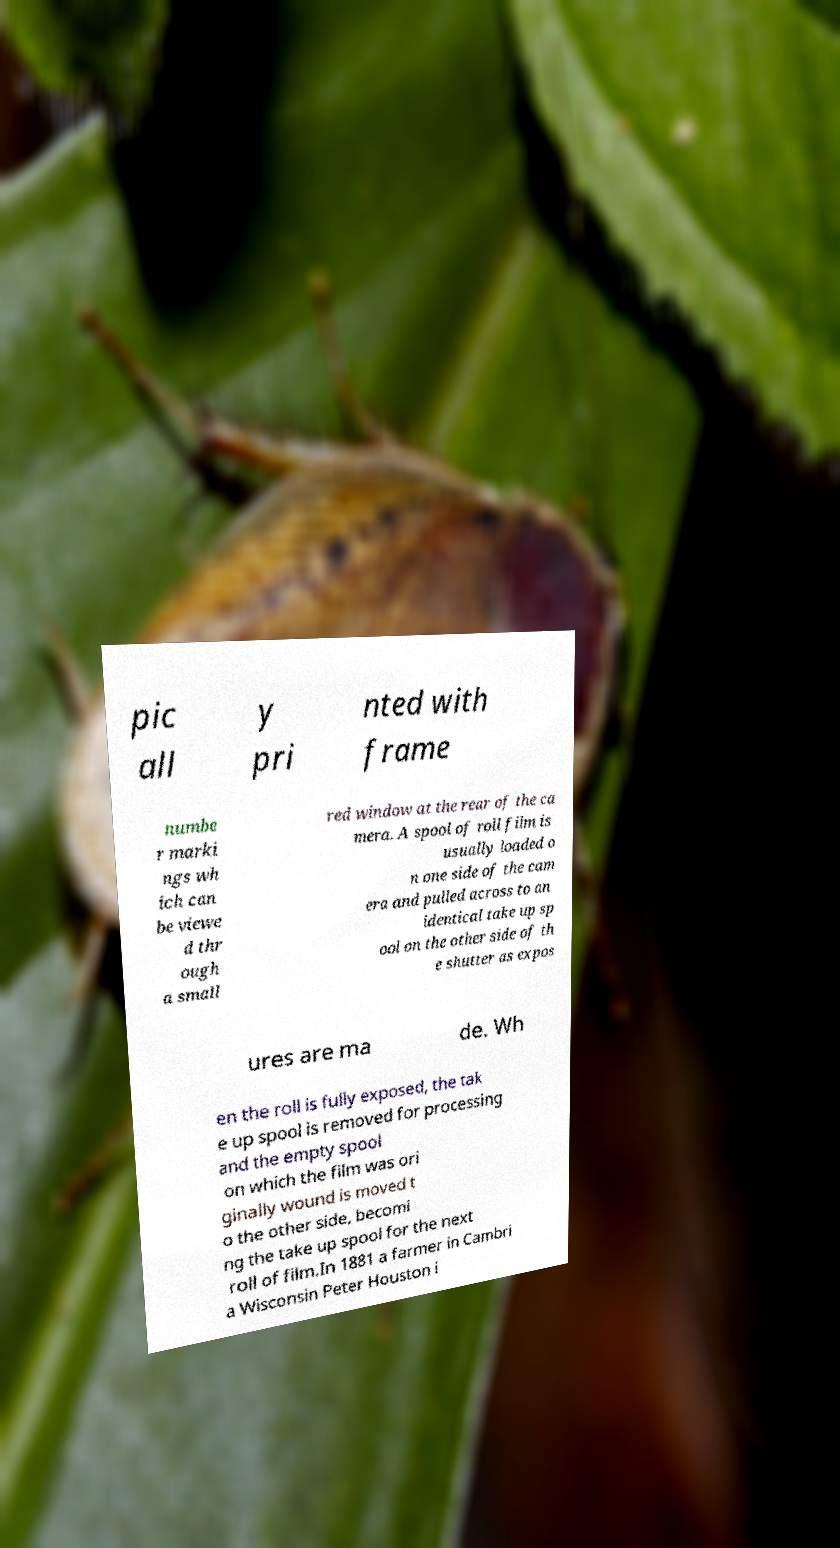What messages or text are displayed in this image? I need them in a readable, typed format. pic all y pri nted with frame numbe r marki ngs wh ich can be viewe d thr ough a small red window at the rear of the ca mera. A spool of roll film is usually loaded o n one side of the cam era and pulled across to an identical take up sp ool on the other side of th e shutter as expos ures are ma de. Wh en the roll is fully exposed, the tak e up spool is removed for processing and the empty spool on which the film was ori ginally wound is moved t o the other side, becomi ng the take up spool for the next roll of film.In 1881 a farmer in Cambri a Wisconsin Peter Houston i 